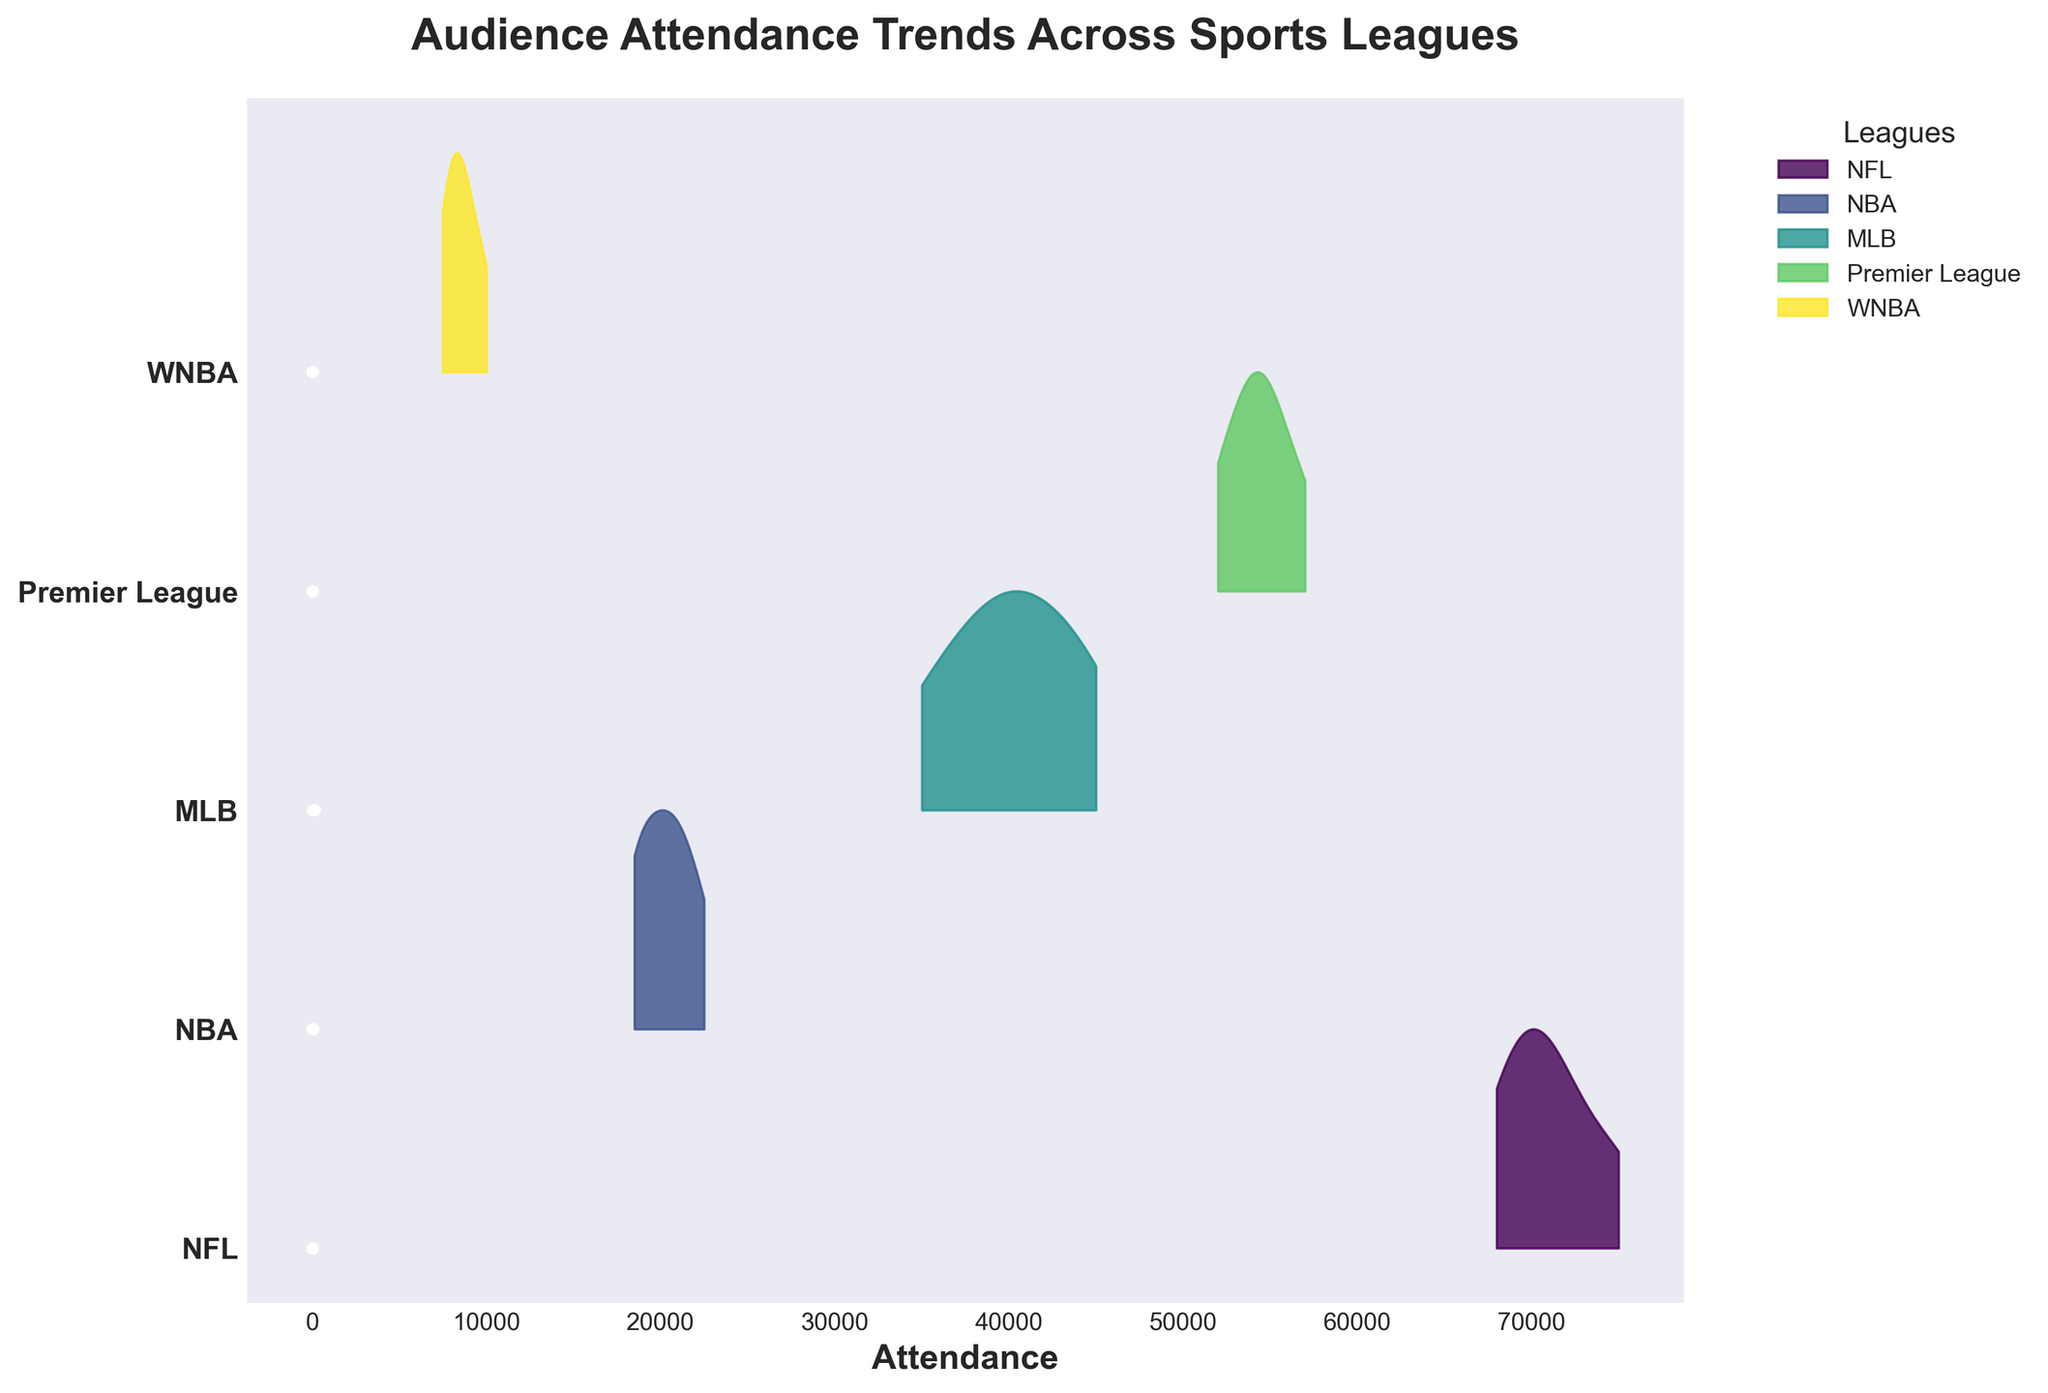What is the title of the plot? The title of the plot is positioned at the top and clearly states the main focus of the figure.
Answer: Audience Attendance Trends Across Sports Leagues Which sports league has the highest attendance at week 20? To find this, look at the week 20 mark along the weeks for each league. The NFL shows the highest attendance at week 20.
Answer: NFL How does the attendance trend of the Premier League compare to the NBA throughout the season? Compare the shape and position of their ridgelines. The Premier League consistently shows higher attendance than the NBA, with the NBA showing a gradual increase.
Answer: Premier League has higher attendance Which league shows the most consistent attendance, and how can you tell? A consistent attendance would have a relatively flat ridgeline. The Premier League has a smoother, flatter gradient compared to others.
Answer: Premier League What is the attendance range for the WNBA? Identify the WNBA curve span on the attendance axis. It ranges approximately from 7,500 to 10,000.
Answer: 7,500 to 10,000 How many distinct leagues are represented in the plot? Count the number of distinct horizontal ridgelines. There are five distinct leagues represented.
Answer: 5 Which league shows the highest peak attendance and in which week does this occur? Look for the highest point on the ridgeline. The NFL shows the highest peak at week 20 with 75,000.
Answer: NFL, week 20 Is there a visible increase in attendance over time for the MLB? The ridgeline for MLB shows increasing peaks as you move right, indicating higher attendance towards the end of the season.
Answer: Yes, there is an increase How does the attendance trend of the NFL differ from the WNBA? The NFL has much higher peaks and more variation, while the WNBA shows a more gradual increase with lower attendance.
Answer: NFL has higher peaks and more variation At which point do the NBA and WNBA attendances intersect, if at all? Trace the ridgelines of NBA and WNBA and find if they meet at any point. They do not intersect; the NBA consistently has higher attendance than the WNBA.
Answer: They do not intersect 